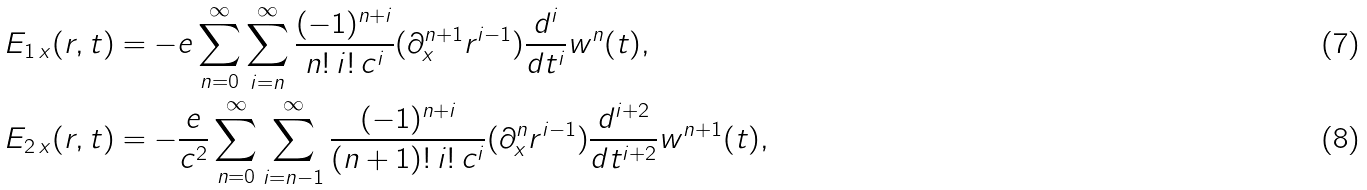<formula> <loc_0><loc_0><loc_500><loc_500>& E _ { 1 \, x } ( { r } , t ) = - e \sum _ { n = 0 } ^ { \infty } \sum _ { i = n } ^ { \infty } \frac { ( - 1 ) ^ { n + i } } { n ! \, i ! \, c ^ { i } } ( \partial _ { x } ^ { n + 1 } r ^ { i - 1 } ) \frac { d ^ { i } } { d t ^ { i } } w ^ { n } ( t ) , \\ & E _ { 2 \, x } ( { r } , t ) = - \frac { e } { c ^ { 2 } } \sum _ { n = 0 } ^ { \infty } \sum _ { i = n - 1 } ^ { \infty } \frac { ( - 1 ) ^ { n + i } } { ( n + 1 ) ! \, i ! \, c ^ { i } } ( \partial _ { x } ^ { n } r ^ { i - 1 } ) \frac { d ^ { i + 2 } } { d t ^ { i + 2 } } w ^ { n + 1 } ( t ) ,</formula> 